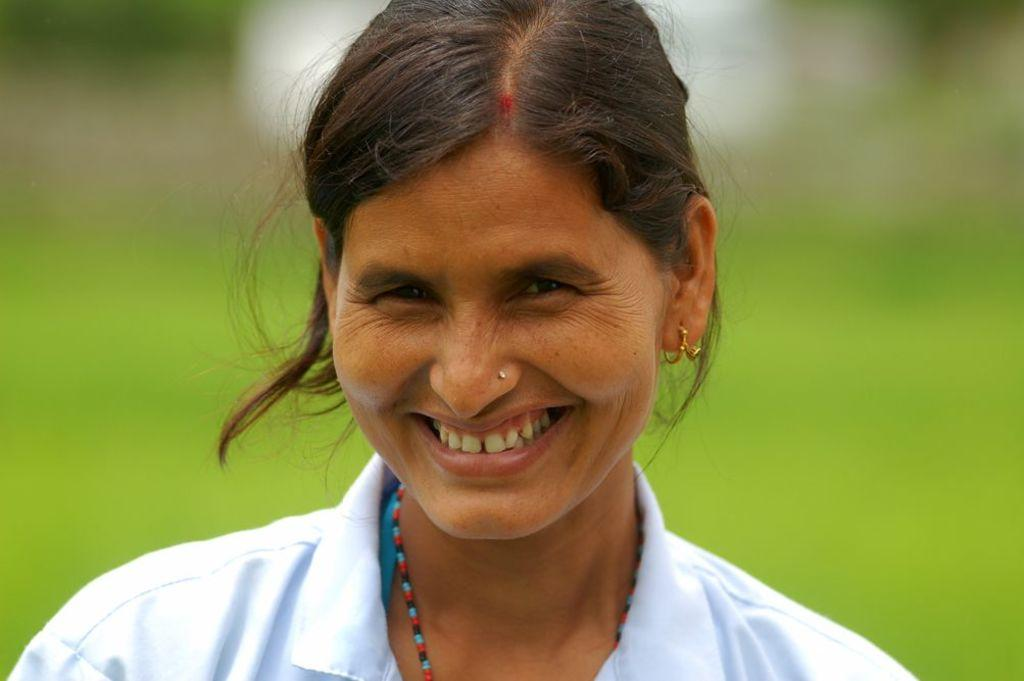Who is present in the image? There is a woman in the image. What is the woman doing in the image? The woman is smiling in the image. What is the woman wearing in the image? The woman is wearing a white dress in the image. What colors can be seen in the background of the image? The background of the image is green and white. What type of night attraction can be seen in the image? There is no night attraction present in the image; it features a woman smiling and wearing a white dress against a green and white background. 